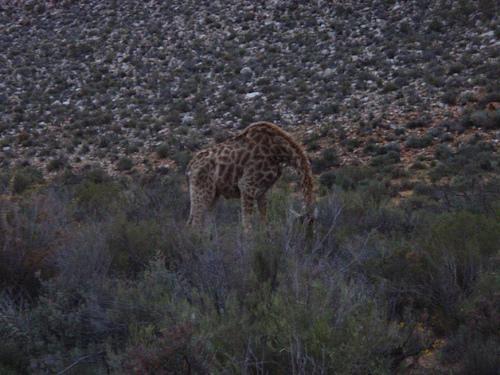How many giraffes are there?
Give a very brief answer. 1. 